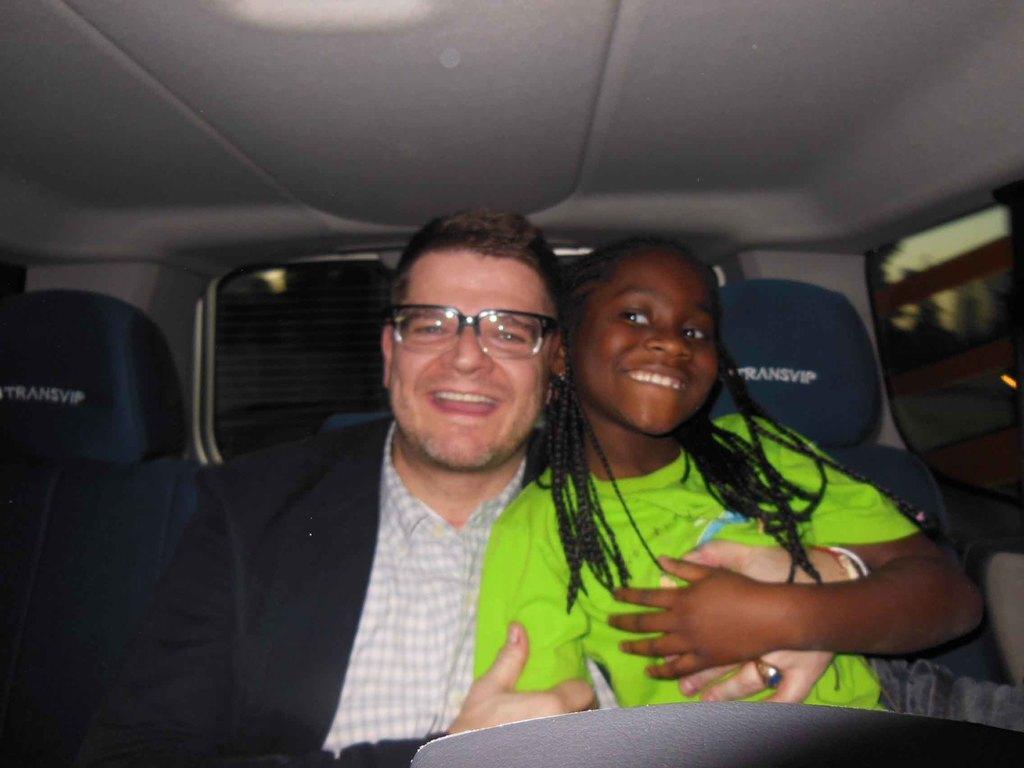Describe this image in one or two sentences. In this image there are two persons sitting in the car. The man at the left side is having smile on his face. The boy at the right side wearing green colour shirt is smiling. In the background there are two seats. 